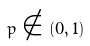Convert formula to latex. <formula><loc_0><loc_0><loc_500><loc_500>p \notin ( 0 , 1 )</formula> 